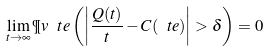Convert formula to latex. <formula><loc_0><loc_0><loc_500><loc_500>\lim _ { t \to \infty } \P v _ { \ } t e \left ( \left | \frac { Q ( t ) } { t } - C ( \ t e ) \right | > \delta \right ) = 0</formula> 